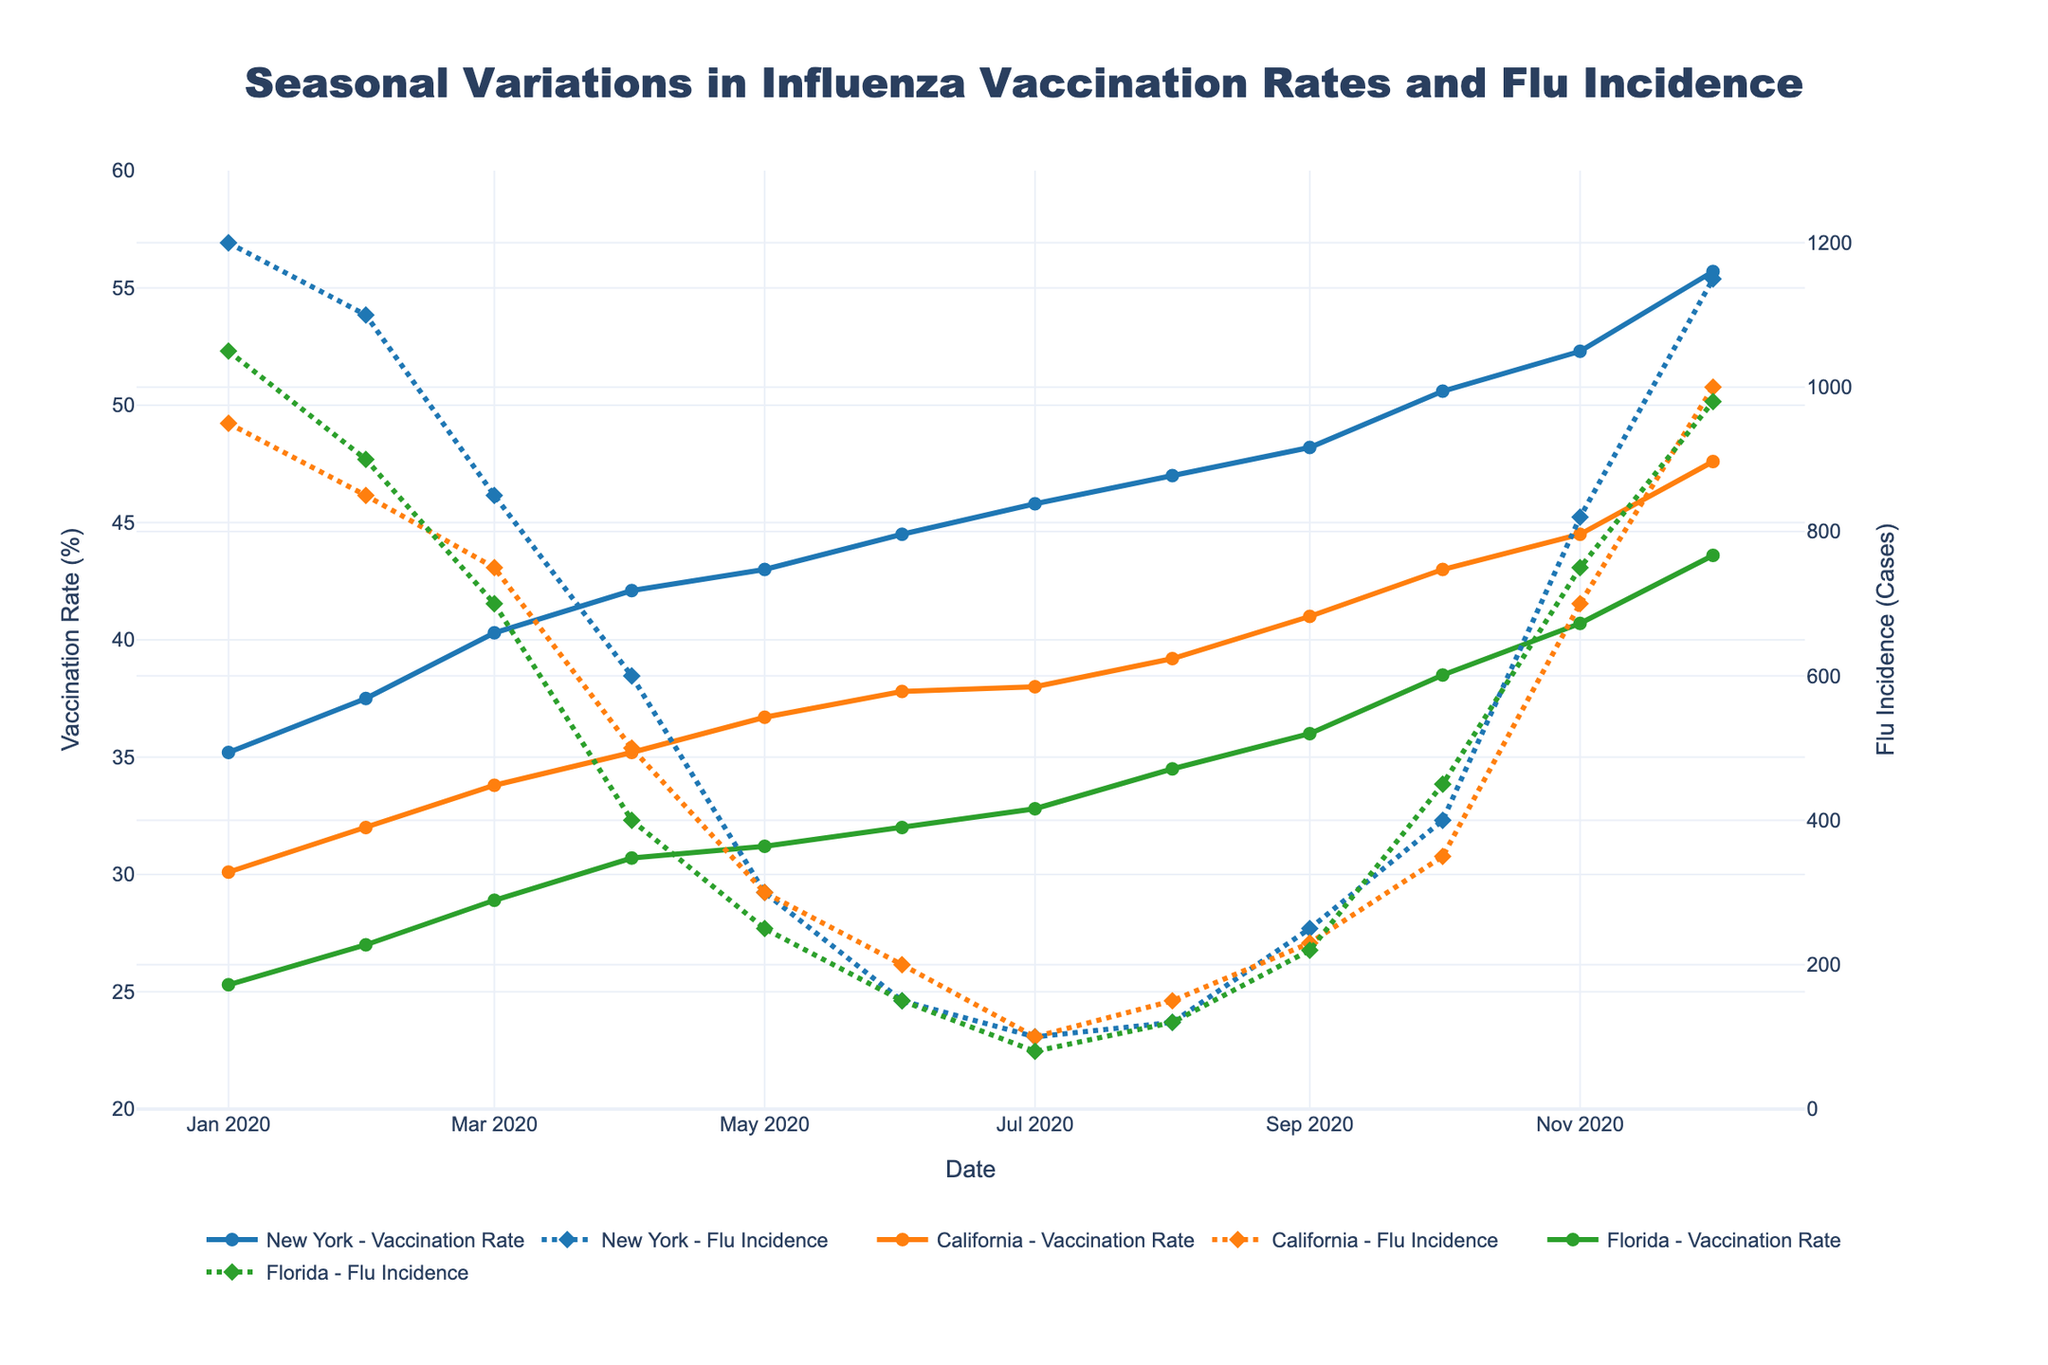What is the title of the figure? The title of the figure is found at the top, often in a larger and bolder font compared to other text on the figure.
Answer: Seasonal Variations in Influenza Vaccination Rates and Flu Incidence What are the y-axis titles for the left and right sides of the chart? The y-axis titles are text labels next to the vertical axes on the left and right sides of the figure.
Answer: Vaccination Rate (%) and Flu Incidence (Cases) What color represents the vaccination rate for Florida? The color representing the vaccination rate for Florida can be identified by observing the lines and markers corresponding to Florida’s vaccination rate and checking its corresponding color in the legend.
Answer: Green What month had the lowest flu incidence in New York during 2020? To determine the month with the lowest flu incidence, check the secondary y-axis, follow the data points for New York, and identify the month with the smallest value.
Answer: July By how much did the vaccination rate increase in California from January to December 2020? Calculate the difference between the vaccination rate in January and December for California by subtracting the January value from the December value. January's rate is 30.1%, and December's rate is 47.6%.
Answer: 17.5% Which location had the highest peak of flu incidence, and in which month did it occur? To find this, compare the highest data points of flu incidence lines for all three locations. Check which location has the maximum peak and identify the corresponding month.
Answer: New York in January During which months did New York have a higher flu incidence than California? Compare the data points on the secondary y-axis for New York and California across all months and note where New York's values are higher.
Answer: January, February, March, April, October, November, December What is the overall trend observed in flu incidence from January to December 2020 across all three locations? The overall trend can be identified by visually inspecting the lines corresponding to flu incidence, observing whether they generally increase, decrease, or show mixed patterns over the year.
Answer: Decreasing trend In which month did Florida reach a vaccination rate of approximately 40%? Locate the data points for Florida's vaccination rate on the left y-axis and determine which month's value is closest to 40%.
Answer: November On average, how much did the vaccination rate increase each month in New York? Calculate the monthly average increase by subtracting the vaccination rate in January from December, then divide by the number of months (11 intervals). (55.7% - 35.2%) / 11
Answer: 1.87% per month 